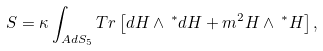Convert formula to latex. <formula><loc_0><loc_0><loc_500><loc_500>S = \kappa \int _ { A d S _ { 5 } } { T r } \left [ d H \wedge \, ^ { * } d H + m ^ { 2 } H \wedge \, ^ { * } H \right ] ,</formula> 